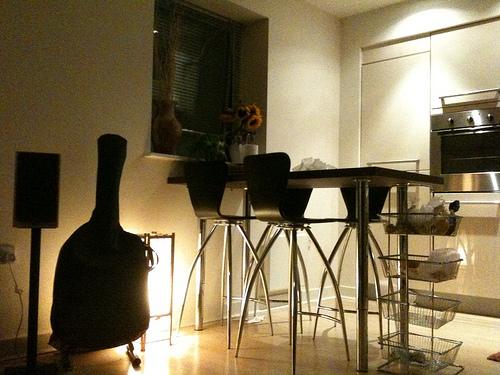What appliance is in the wall with three knobs?
Concise answer only. Oven. Is the furniture modern?
Answer briefly. Yes. How many animals in the picture?
Write a very short answer. 0. 